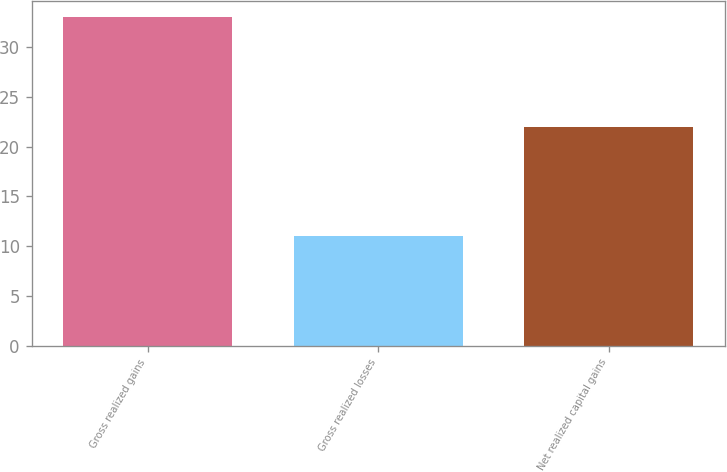Convert chart. <chart><loc_0><loc_0><loc_500><loc_500><bar_chart><fcel>Gross realized gains<fcel>Gross realized losses<fcel>Net realized capital gains<nl><fcel>33<fcel>11<fcel>22<nl></chart> 